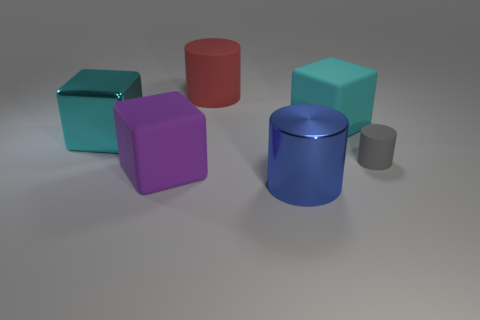What is the shape of the small gray thing that is the same material as the large purple thing?
Offer a terse response. Cylinder. There is a big object left of the purple matte cube; is it the same shape as the large cyan rubber thing?
Offer a terse response. Yes. How many green objects are big shiny blocks or large objects?
Keep it short and to the point. 0. Are there the same number of large matte cylinders that are to the right of the large blue shiny cylinder and metallic things to the left of the purple object?
Provide a succinct answer. No. What color is the rubber cylinder behind the matte cube that is behind the tiny matte object in front of the big shiny cube?
Provide a short and direct response. Red. Is there any other thing that is the same color as the large metallic cube?
Your response must be concise. Yes. There is a large rubber object that is the same color as the large metallic cube; what is its shape?
Make the answer very short. Cube. There is a cyan object that is to the right of the purple rubber thing; how big is it?
Ensure brevity in your answer.  Large. What is the shape of the red matte thing that is the same size as the cyan rubber block?
Provide a succinct answer. Cylinder. Does the cylinder behind the tiny matte cylinder have the same material as the block in front of the gray rubber thing?
Ensure brevity in your answer.  Yes. 